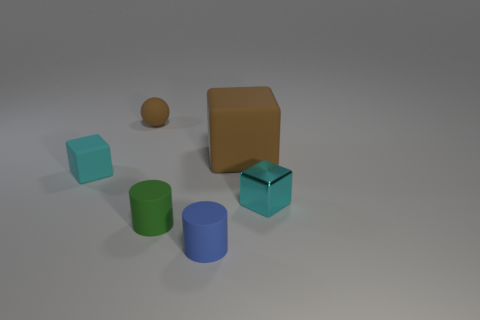Subtract all rubber blocks. How many blocks are left? 1 Subtract all cyan blocks. How many blocks are left? 1 Add 3 large cyan rubber cylinders. How many objects exist? 9 Subtract all balls. How many objects are left? 5 Subtract 2 cubes. How many cubes are left? 1 Subtract all purple balls. How many cyan cubes are left? 2 Subtract all brown matte objects. Subtract all small brown rubber spheres. How many objects are left? 3 Add 2 small blue things. How many small blue things are left? 3 Add 6 brown matte objects. How many brown matte objects exist? 8 Subtract 0 cyan balls. How many objects are left? 6 